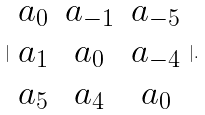<formula> <loc_0><loc_0><loc_500><loc_500>| \begin{array} { c c c } a _ { 0 } & a _ { - 1 } & a _ { - 5 } \\ a _ { 1 } & a _ { 0 } & a _ { - 4 } \\ a _ { 5 } & a _ { 4 } & a _ { 0 } \end{array} | .</formula> 